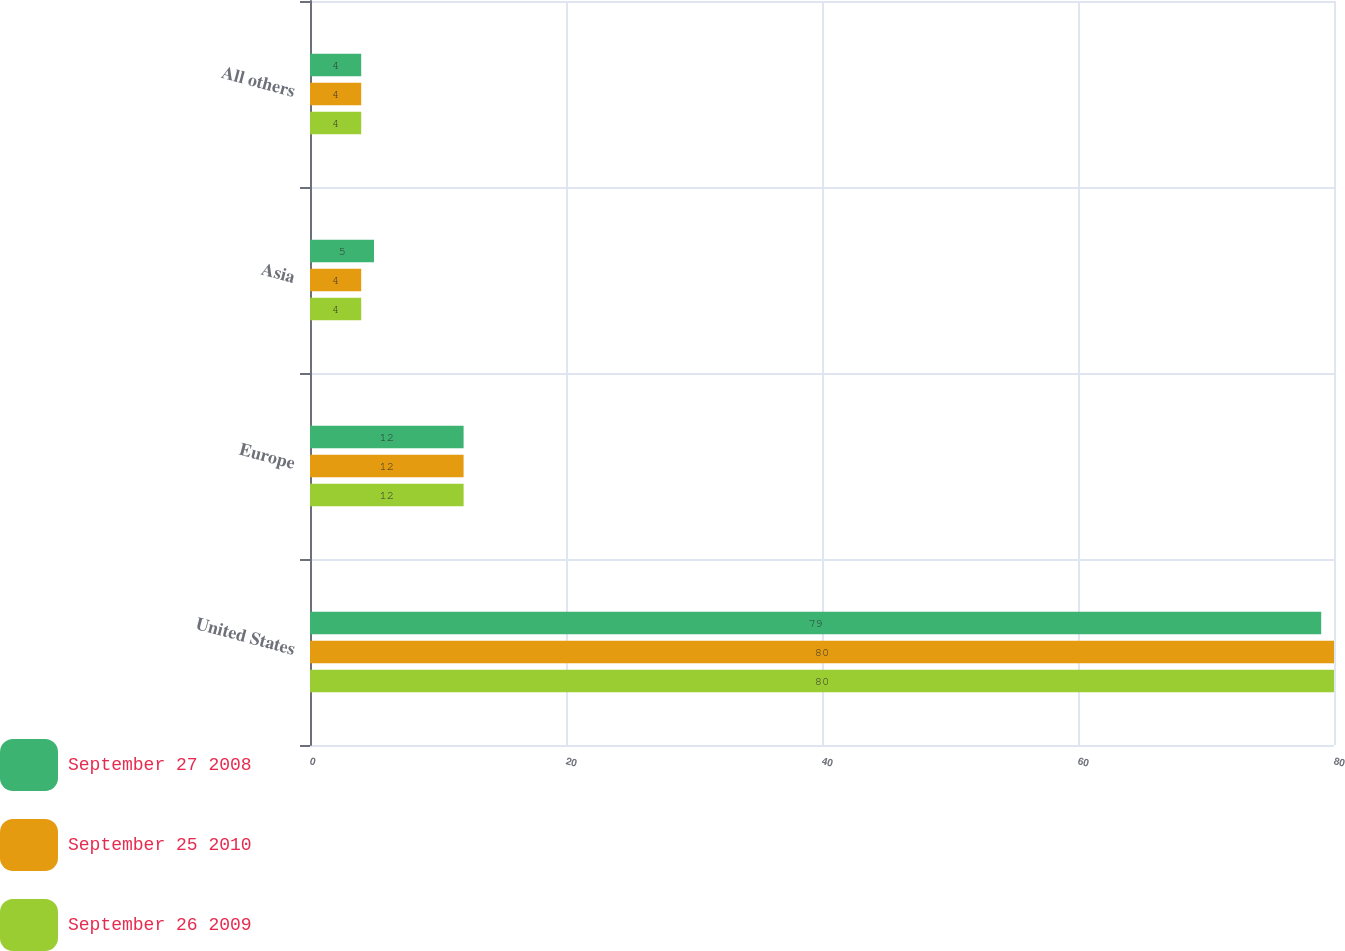Convert chart. <chart><loc_0><loc_0><loc_500><loc_500><stacked_bar_chart><ecel><fcel>United States<fcel>Europe<fcel>Asia<fcel>All others<nl><fcel>September 27 2008<fcel>79<fcel>12<fcel>5<fcel>4<nl><fcel>September 25 2010<fcel>80<fcel>12<fcel>4<fcel>4<nl><fcel>September 26 2009<fcel>80<fcel>12<fcel>4<fcel>4<nl></chart> 